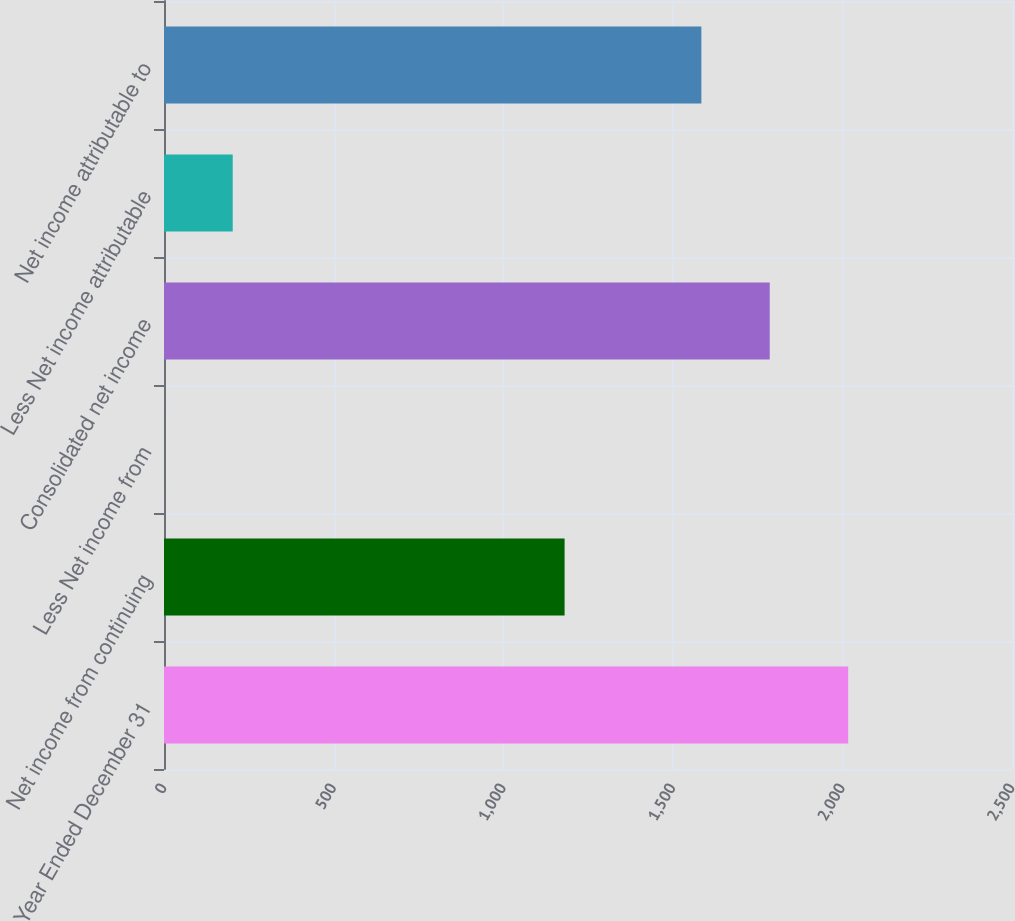<chart> <loc_0><loc_0><loc_500><loc_500><bar_chart><fcel>Year Ended December 31<fcel>Net income from continuing<fcel>Less Net income from<fcel>Consolidated net income<fcel>Less Net income attributable<fcel>Net income attributable to<nl><fcel>2017<fcel>1181<fcel>1<fcel>1785.8<fcel>202.6<fcel>1584.2<nl></chart> 